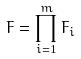Convert formula to latex. <formula><loc_0><loc_0><loc_500><loc_500>F = \prod _ { i = 1 } ^ { m } F _ { i }</formula> 